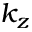Convert formula to latex. <formula><loc_0><loc_0><loc_500><loc_500>k _ { z }</formula> 